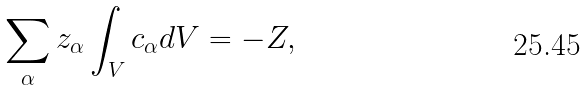<formula> <loc_0><loc_0><loc_500><loc_500>\sum _ { \alpha } z _ { \alpha } \int _ { V } c _ { \alpha } d V = - Z ,</formula> 